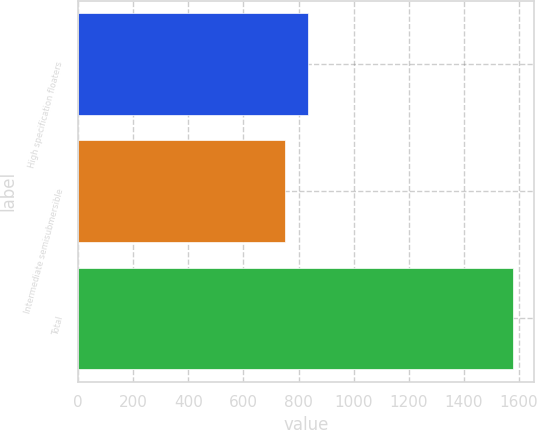<chart> <loc_0><loc_0><loc_500><loc_500><bar_chart><fcel>High specification floaters<fcel>Intermediate semisubmersible<fcel>Total<nl><fcel>833.6<fcel>751<fcel>1577<nl></chart> 